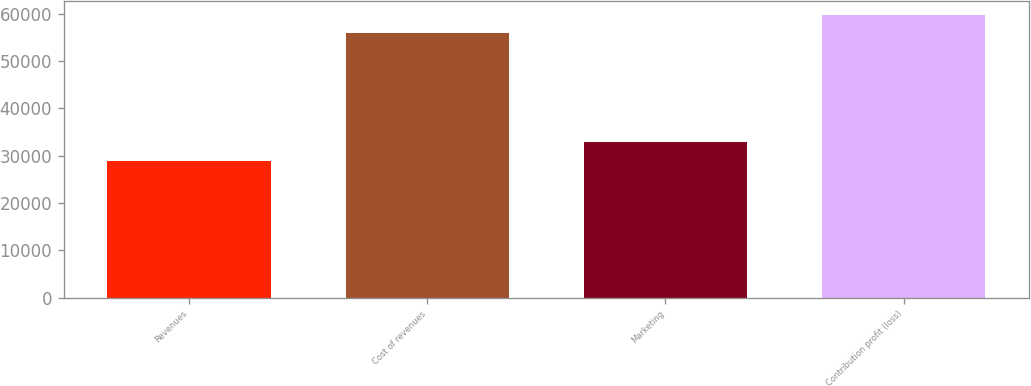Convert chart to OTSL. <chart><loc_0><loc_0><loc_500><loc_500><bar_chart><fcel>Revenues<fcel>Cost of revenues<fcel>Marketing<fcel>Contribution profit (loss)<nl><fcel>28988<fcel>55909<fcel>32822<fcel>59743<nl></chart> 